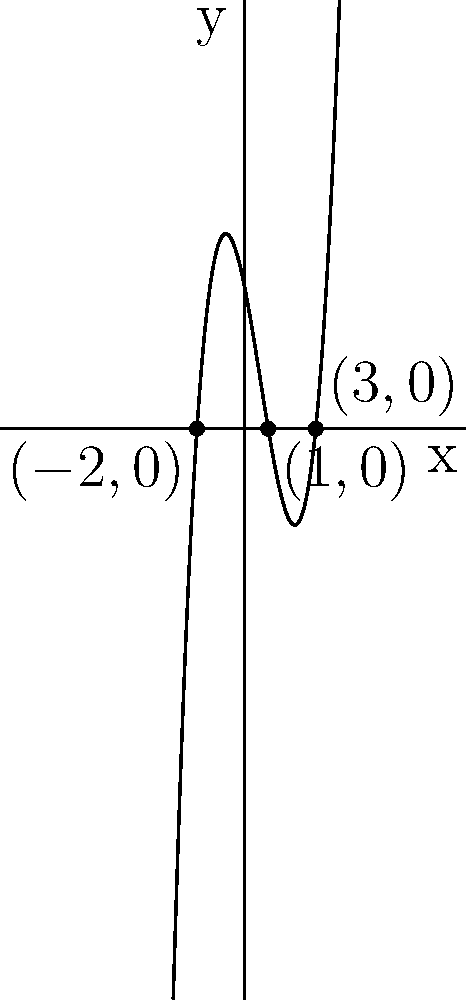Consider the polynomial function $f(x) = (x+2)(x-1)(x-3)$, which represents different pain relief options during childbirth. Sketch the graph of this function and identify its x-intercepts. How does this relate to the effectiveness of various pain management techniques? To sketch the graph and find the x-intercepts:

1. Factor the polynomial: $f(x) = (x+2)(x-1)(x-3)$
2. Identify x-intercepts by setting each factor to zero:
   $x+2 = 0$, $x = -2$
   $x-1 = 0$, $x = 1$
   $x-3 = 0$, $x = 3$
3. Plot x-intercepts: $(-2,0)$, $(1,0)$, and $(3,0)$
4. Determine y-intercept: $f(0) = (0+2)(0-1)(0-3) = 6$
5. Analyze end behavior:
   As $x \to \infty$, $f(x) \to \infty$
   As $x \to -\infty$, $f(x) \to -\infty$
6. Sketch the curve passing through all identified points

Relating to pain management:
- x-axis represents time or intensity of pain relief methods
- y-axis represents effectiveness
- x-intercepts show points where the method's effectiveness changes
- The curve illustrates how the effectiveness of pain relief varies over time or intensity
Answer: x-intercepts: $(-2,0)$, $(1,0)$, $(3,0)$; curve passes through these points and $(0,6)$, with negative values between $-2$ and $1$, and positive values elsewhere. 